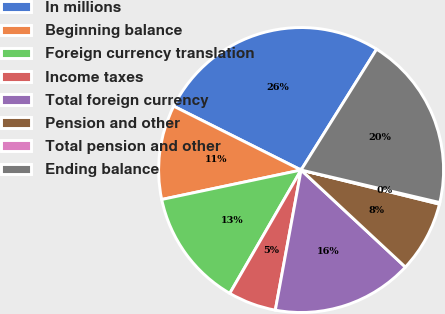Convert chart to OTSL. <chart><loc_0><loc_0><loc_500><loc_500><pie_chart><fcel>In millions<fcel>Beginning balance<fcel>Foreign currency translation<fcel>Income taxes<fcel>Total foreign currency<fcel>Pension and other<fcel>Total pension and other<fcel>Ending balance<nl><fcel>26.5%<fcel>10.71%<fcel>13.34%<fcel>5.45%<fcel>15.97%<fcel>8.08%<fcel>0.18%<fcel>19.78%<nl></chart> 